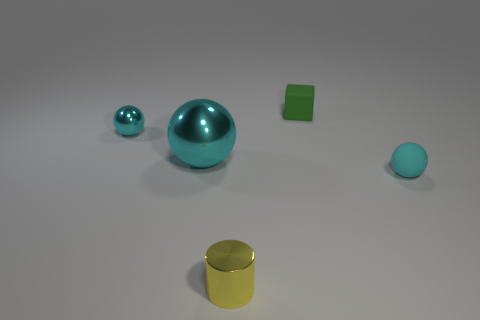There is a tiny shiny thing in front of the small sphere right of the small green thing; what color is it?
Ensure brevity in your answer.  Yellow. There is another tiny cyan object that is the same shape as the cyan rubber thing; what is it made of?
Offer a very short reply. Metal. How many purple shiny objects are the same size as the yellow cylinder?
Provide a short and direct response. 0. The small cylinder that is the same material as the large object is what color?
Offer a very short reply. Yellow. Are there fewer small green rubber objects than small cyan things?
Provide a succinct answer. Yes. What number of cyan objects are shiny balls or small matte cylinders?
Your answer should be very brief. 2. What number of small things are to the right of the small yellow object and in front of the green object?
Offer a very short reply. 1. Do the yellow object and the large thing have the same material?
Provide a succinct answer. Yes. There is a cyan rubber thing that is the same size as the yellow object; what shape is it?
Keep it short and to the point. Sphere. Are there more rubber objects than shiny objects?
Your response must be concise. No. 